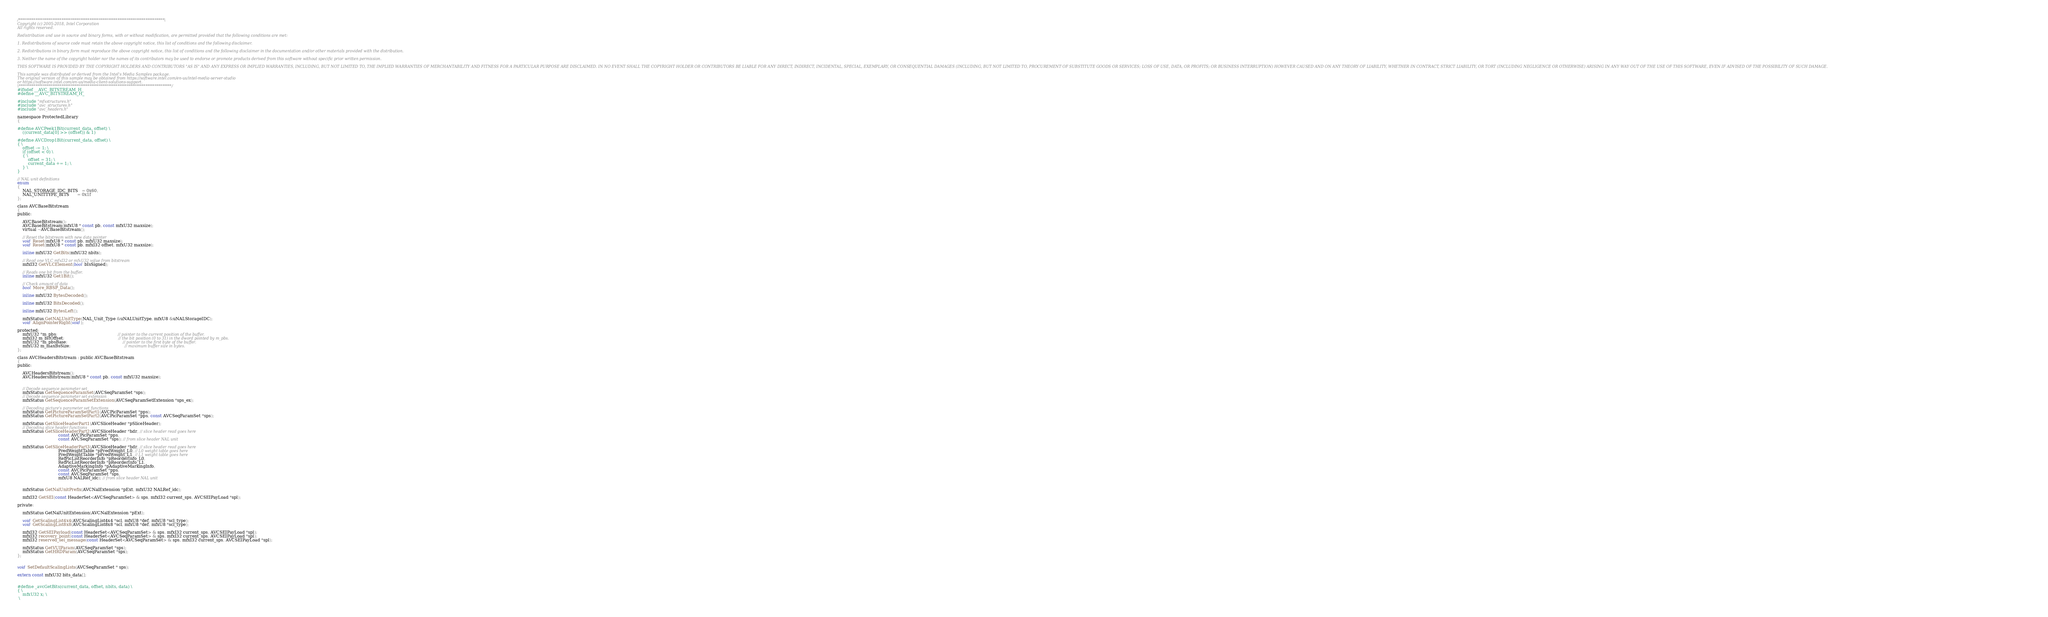<code> <loc_0><loc_0><loc_500><loc_500><_C_>/******************************************************************************\
Copyright (c) 2005-2018, Intel Corporation
All rights reserved.

Redistribution and use in source and binary forms, with or without modification, are permitted provided that the following conditions are met:

1. Redistributions of source code must retain the above copyright notice, this list of conditions and the following disclaimer.

2. Redistributions in binary form must reproduce the above copyright notice, this list of conditions and the following disclaimer in the documentation and/or other materials provided with the distribution.

3. Neither the name of the copyright holder nor the names of its contributors may be used to endorse or promote products derived from this software without specific prior written permission.

THIS SOFTWARE IS PROVIDED BY THE COPYRIGHT HOLDERS AND CONTRIBUTORS "AS IS" AND ANY EXPRESS OR IMPLIED WARRANTIES, INCLUDING, BUT NOT LIMITED TO, THE IMPLIED WARRANTIES OF MERCHANTABILITY AND FITNESS FOR A PARTICULAR PURPOSE ARE DISCLAIMED. IN NO EVENT SHALL THE COPYRIGHT HOLDER OR CONTRIBUTORS BE LIABLE FOR ANY DIRECT, INDIRECT, INCIDENTAL, SPECIAL, EXEMPLARY, OR CONSEQUENTIAL DAMAGES (INCLUDING, BUT NOT LIMITED TO, PROCUREMENT OF SUBSTITUTE GOODS OR SERVICES; LOSS OF USE, DATA, OR PROFITS; OR BUSINESS INTERRUPTION) HOWEVER CAUSED AND ON ANY THEORY OF LIABILITY, WHETHER IN CONTRACT, STRICT LIABILITY, OR TORT (INCLUDING NEGLIGENCE OR OTHERWISE) ARISING IN ANY WAY OUT OF THE USE OF THIS SOFTWARE, EVEN IF ADVISED OF THE POSSIBILITY OF SUCH DAMAGE.

This sample was distributed or derived from the Intel's Media Samples package.
The original version of this sample may be obtained from https://software.intel.com/en-us/intel-media-server-studio
or https://software.intel.com/en-us/media-client-solutions-support.
\**********************************************************************************/
#ifndef __AVC_BITSTREAM_H_
#define __AVC_BITSTREAM_H_

#include "mfxstructures.h"
#include "avc_structures.h"
#include "avc_headers.h"

namespace ProtectedLibrary
{

#define AVCPeek1Bit(current_data, offset) \
    ((current_data[0] >> (offset)) & 1)

#define AVCDrop1Bit(current_data, offset) \
{ \
    offset -= 1; \
    if (offset < 0) \
    { \
        offset = 31; \
        current_data += 1; \
    } \
}

// NAL unit definitions
enum
{
    NAL_STORAGE_IDC_BITS   = 0x60,
    NAL_UNITTYPE_BITS      = 0x1f
};

class AVCBaseBitstream
{
public:

    AVCBaseBitstream();
    AVCBaseBitstream(mfxU8 * const pb, const mfxU32 maxsize);
    virtual ~AVCBaseBitstream();

    // Reset the bitstream with new data pointer
    void Reset(mfxU8 * const pb, mfxU32 maxsize);
    void Reset(mfxU8 * const pb, mfxI32 offset, mfxU32 maxsize);

    inline mfxU32 GetBits(mfxU32 nbits);

    // Read one VLC mfxI32 or mfxU32 value from bitstream
    mfxI32 GetVLCElement(bool bIsSigned);

    // Reads one bit from the buffer.
    inline mfxU32 Get1Bit();

    // Check amount of data
    bool More_RBSP_Data();

    inline mfxU32 BytesDecoded();

    inline mfxU32 BitsDecoded();

    inline mfxU32 BytesLeft();

    mfxStatus GetNALUnitType(NAL_Unit_Type &uNALUnitType, mfxU8 &uNALStorageIDC);
    void AlignPointerRight(void);

protected:
    mfxU32 *m_pbs;                                              // pointer to the current position of the buffer.
    mfxI32 m_bitOffset;                                         // the bit position (0 to 31) in the dword pointed by m_pbs.
    mfxU32 *m_pbsBase;                                          // pointer to the first byte of the buffer.
    mfxU32 m_maxBsSize;                                         // maximum buffer size in bytes.
};

class AVCHeadersBitstream : public AVCBaseBitstream
{
public:

    AVCHeadersBitstream();
    AVCHeadersBitstream(mfxU8 * const pb, const mfxU32 maxsize);


    // Decode sequence parameter set
    mfxStatus GetSequenceParamSet(AVCSeqParamSet *sps);
    // Decode sequence parameter set extension
    mfxStatus GetSequenceParamSetExtension(AVCSeqParamSetExtension *sps_ex);

    // Decoding picture's parameter set functions
    mfxStatus GetPictureParamSetPart1(AVCPicParamSet *pps);
    mfxStatus GetPictureParamSetPart2(AVCPicParamSet *pps, const AVCSeqParamSet *sps);

    mfxStatus GetSliceHeaderPart1(AVCSliceHeader *pSliceHeader);
    // Decoding slice header functions
    mfxStatus GetSliceHeaderPart2(AVCSliceHeader *hdr, // slice header read goes here
                               const AVCPicParamSet *pps,
                               const AVCSeqParamSet *sps); // from slice header NAL unit

    mfxStatus GetSliceHeaderPart3(AVCSliceHeader *hdr, // slice header read goes here
                               PredWeightTable *pPredWeight_L0, // L0 weight table goes here
                               PredWeightTable *pPredWeight_L1, // L1 weight table goes here
                               RefPicListReorderInfo *pReorderInfo_L0,
                               RefPicListReorderInfo *pReorderInfo_L1,
                               AdaptiveMarkingInfo *pAdaptiveMarkingInfo,
                               const AVCPicParamSet *pps,
                               const AVCSeqParamSet *sps,
                               mfxU8 NALRef_idc); // from slice header NAL unit


    mfxStatus GetNalUnitPrefix(AVCNalExtension *pExt, mfxU32 NALRef_idc);

    mfxI32 GetSEI(const HeaderSet<AVCSeqParamSet> & sps, mfxI32 current_sps, AVCSEIPayLoad *spl);

private:

    mfxStatus GetNalUnitExtension(AVCNalExtension *pExt);

    void GetScalingList4x4(AVCScalingList4x4 *scl, mfxU8 *def, mfxU8 *scl_type);
    void GetScalingList8x8(AVCScalingList8x8 *scl, mfxU8 *def, mfxU8 *scl_type);

    mfxI32 GetSEIPayload(const HeaderSet<AVCSeqParamSet> & sps, mfxI32 current_sps, AVCSEIPayLoad *spl);
    mfxI32 recovery_point(const HeaderSet<AVCSeqParamSet> & sps, mfxI32 current_sps, AVCSEIPayLoad *spl);
    mfxI32 reserved_sei_message(const HeaderSet<AVCSeqParamSet> & sps, mfxI32 current_sps, AVCSEIPayLoad *spl);

    mfxStatus GetVUIParam(AVCSeqParamSet *sps);
    mfxStatus GetHRDParam(AVCSeqParamSet *sps);
};


void SetDefaultScalingLists(AVCSeqParamSet * sps);

extern const mfxU32 bits_data[];


#define _avcGetBits(current_data, offset, nbits, data) \
{ \
    mfxU32 x; \
 \</code> 